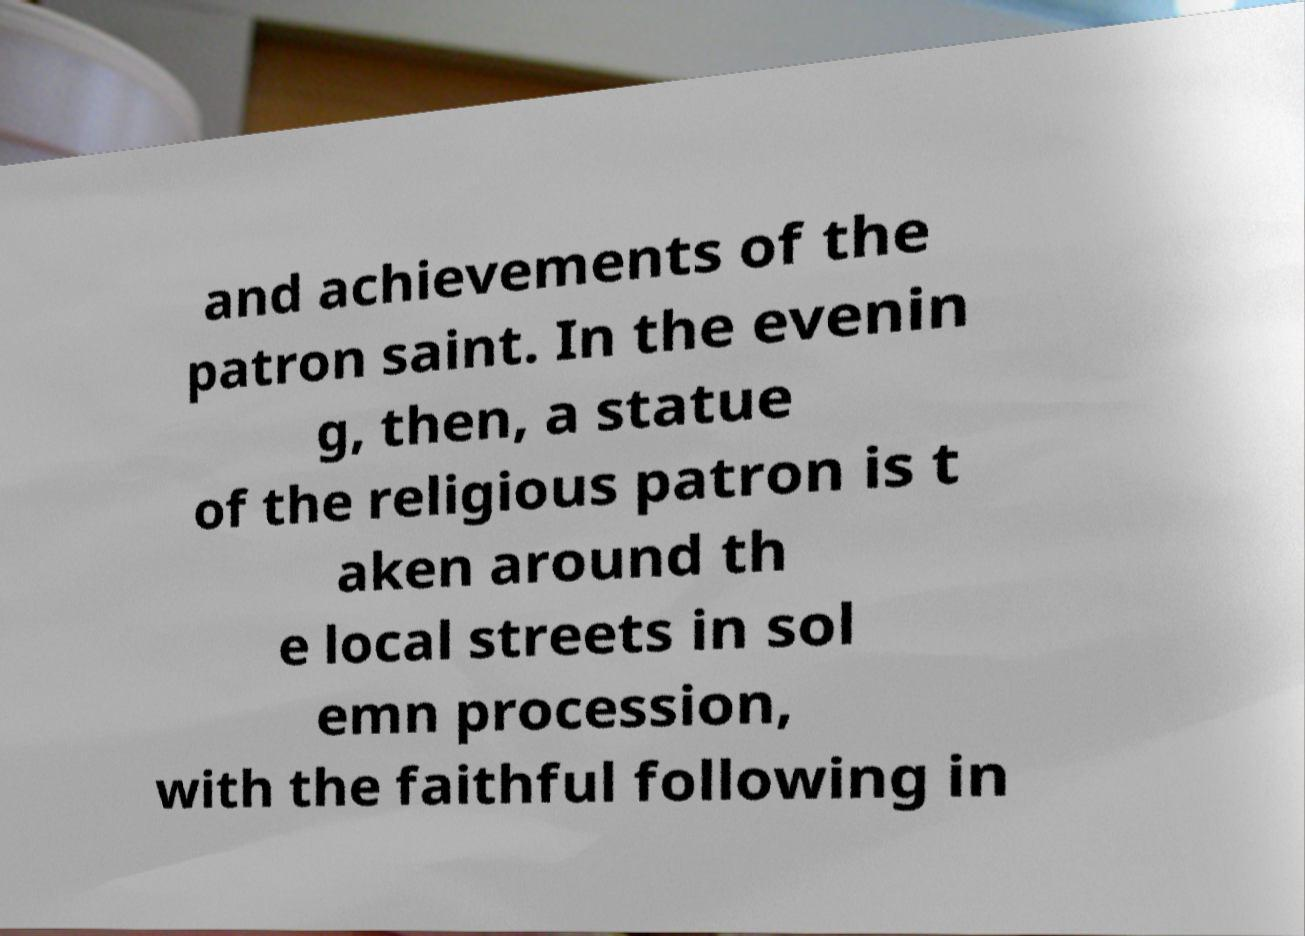Can you read and provide the text displayed in the image?This photo seems to have some interesting text. Can you extract and type it out for me? and achievements of the patron saint. In the evenin g, then, a statue of the religious patron is t aken around th e local streets in sol emn procession, with the faithful following in 